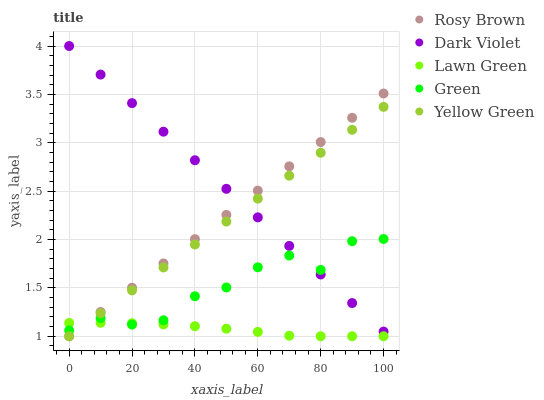Does Lawn Green have the minimum area under the curve?
Answer yes or no. Yes. Does Dark Violet have the maximum area under the curve?
Answer yes or no. Yes. Does Rosy Brown have the minimum area under the curve?
Answer yes or no. No. Does Rosy Brown have the maximum area under the curve?
Answer yes or no. No. Is Dark Violet the smoothest?
Answer yes or no. Yes. Is Green the roughest?
Answer yes or no. Yes. Is Rosy Brown the smoothest?
Answer yes or no. No. Is Rosy Brown the roughest?
Answer yes or no. No. Does Lawn Green have the lowest value?
Answer yes or no. Yes. Does Green have the lowest value?
Answer yes or no. No. Does Dark Violet have the highest value?
Answer yes or no. Yes. Does Rosy Brown have the highest value?
Answer yes or no. No. Is Lawn Green less than Dark Violet?
Answer yes or no. Yes. Is Dark Violet greater than Lawn Green?
Answer yes or no. Yes. Does Lawn Green intersect Green?
Answer yes or no. Yes. Is Lawn Green less than Green?
Answer yes or no. No. Is Lawn Green greater than Green?
Answer yes or no. No. Does Lawn Green intersect Dark Violet?
Answer yes or no. No. 